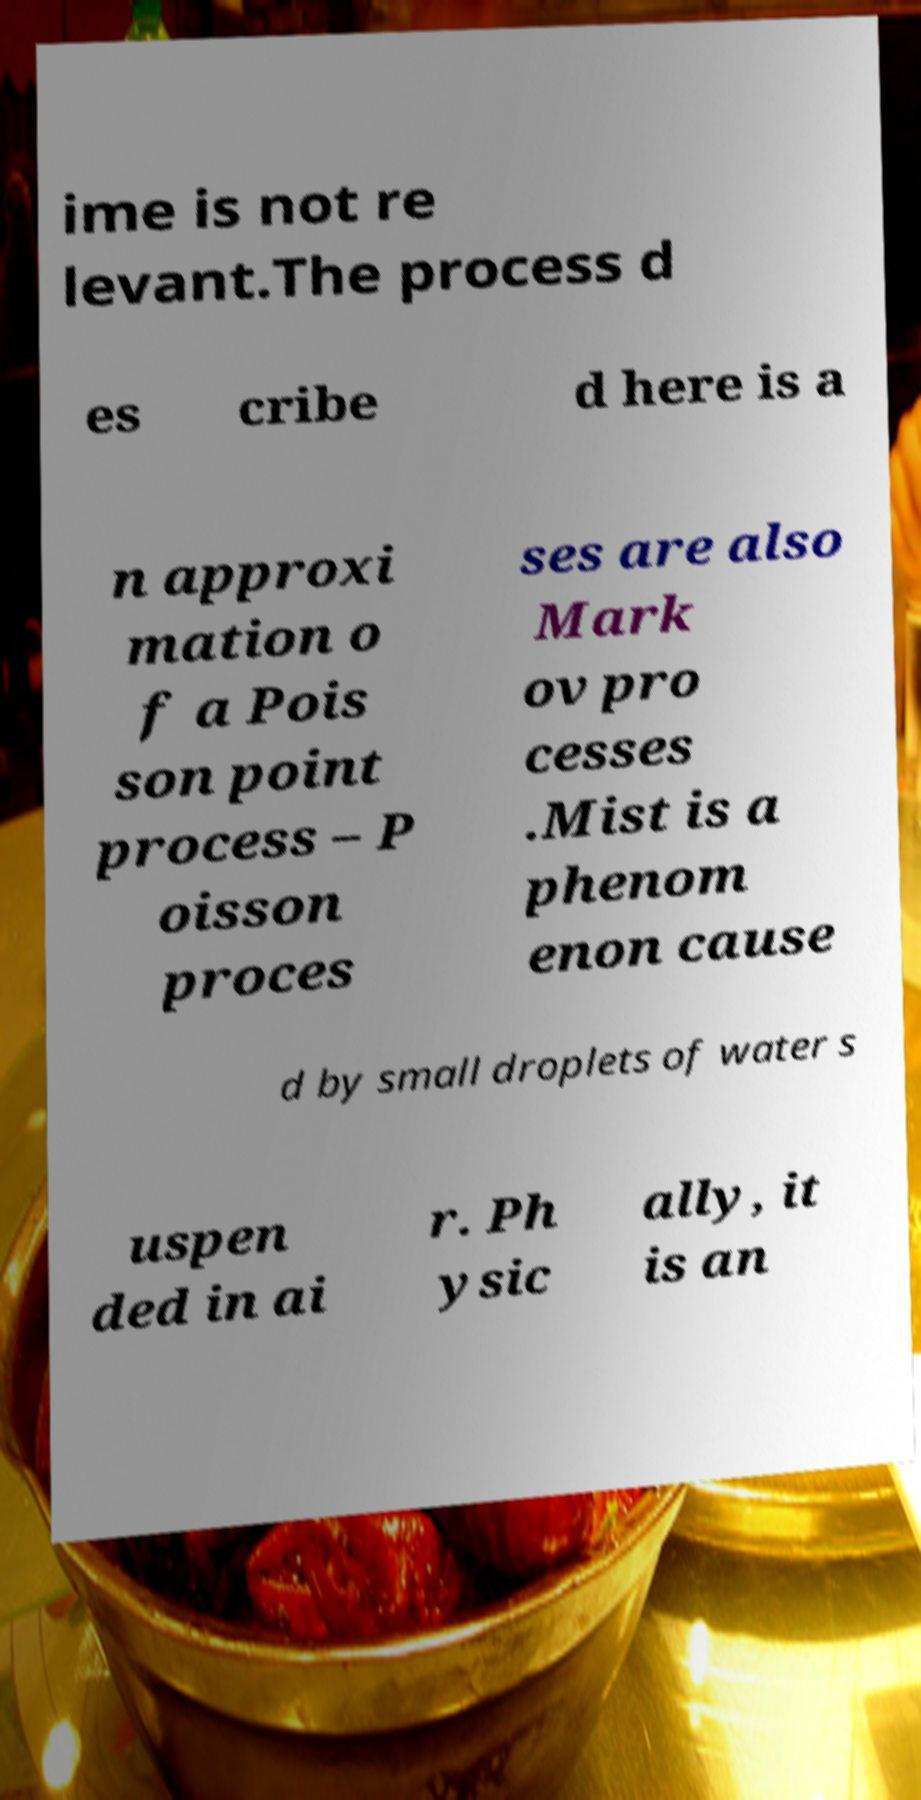For documentation purposes, I need the text within this image transcribed. Could you provide that? ime is not re levant.The process d es cribe d here is a n approxi mation o f a Pois son point process – P oisson proces ses are also Mark ov pro cesses .Mist is a phenom enon cause d by small droplets of water s uspen ded in ai r. Ph ysic ally, it is an 